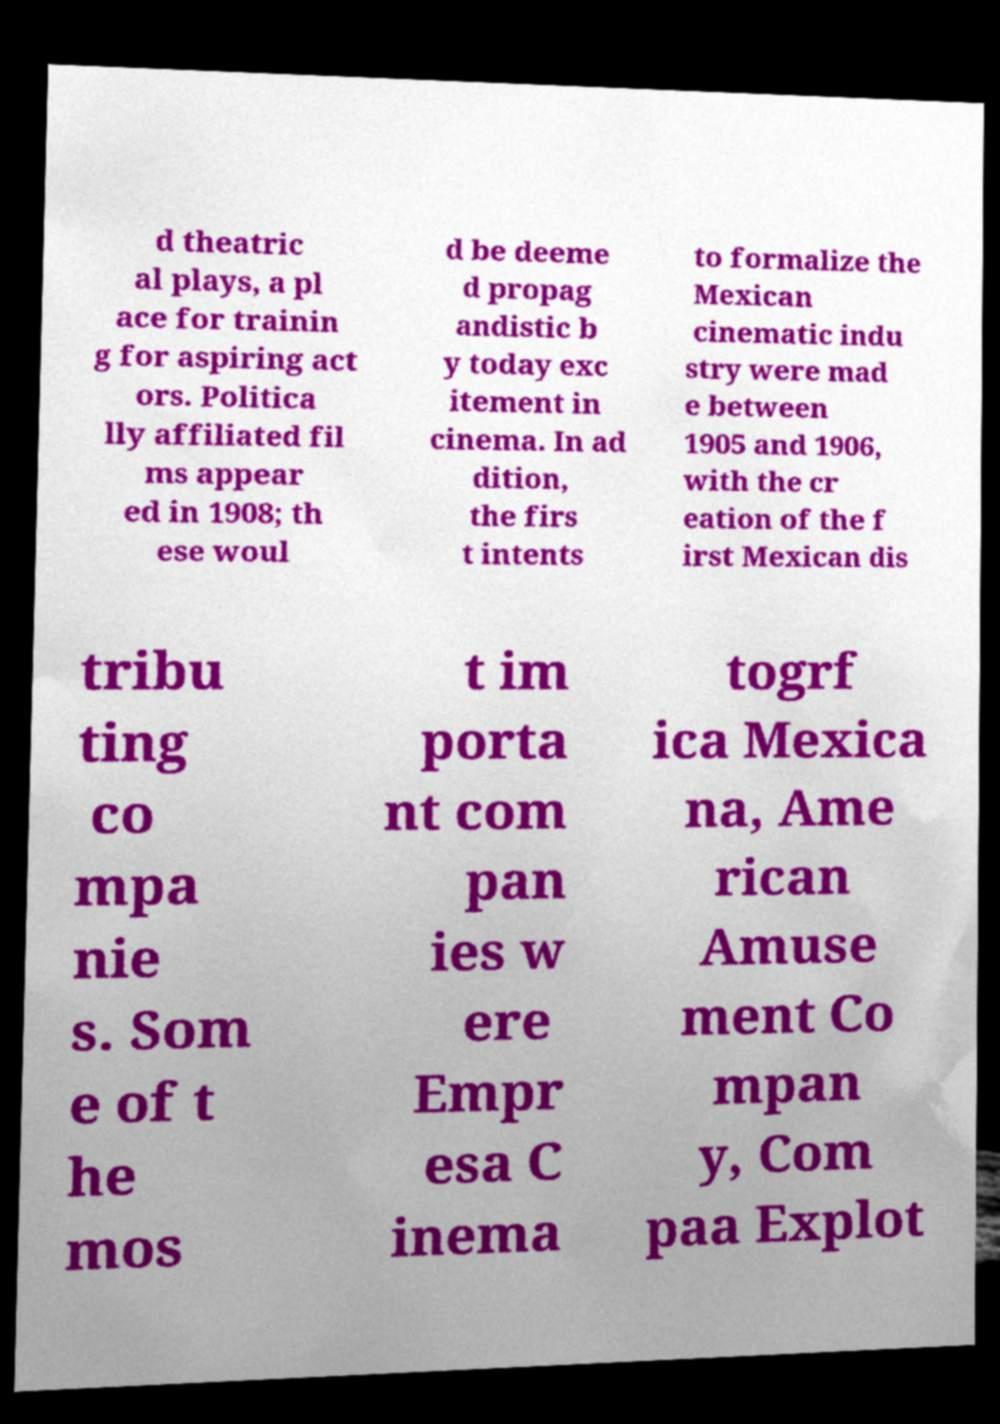I need the written content from this picture converted into text. Can you do that? d theatric al plays, a pl ace for trainin g for aspiring act ors. Politica lly affiliated fil ms appear ed in 1908; th ese woul d be deeme d propag andistic b y today exc itement in cinema. In ad dition, the firs t intents to formalize the Mexican cinematic indu stry were mad e between 1905 and 1906, with the cr eation of the f irst Mexican dis tribu ting co mpa nie s. Som e of t he mos t im porta nt com pan ies w ere Empr esa C inema togrf ica Mexica na, Ame rican Amuse ment Co mpan y, Com paa Explot 